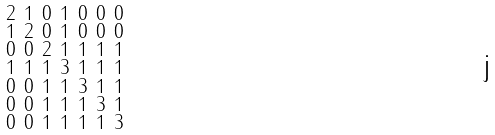<formula> <loc_0><loc_0><loc_500><loc_500>\begin{smallmatrix} 2 & 1 & 0 & 1 & 0 & 0 & 0 \\ 1 & 2 & 0 & 1 & 0 & 0 & 0 \\ 0 & 0 & 2 & 1 & 1 & 1 & 1 \\ 1 & 1 & 1 & 3 & 1 & 1 & 1 \\ 0 & 0 & 1 & 1 & 3 & 1 & 1 \\ 0 & 0 & 1 & 1 & 1 & 3 & 1 \\ 0 & 0 & 1 & 1 & 1 & 1 & 3 \end{smallmatrix}</formula> 